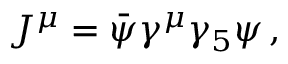<formula> <loc_0><loc_0><loc_500><loc_500>\begin{array} { r } { J ^ { \mu } = \bar { \psi } \gamma ^ { \mu } \gamma _ { 5 } \psi \, , } \end{array}</formula> 